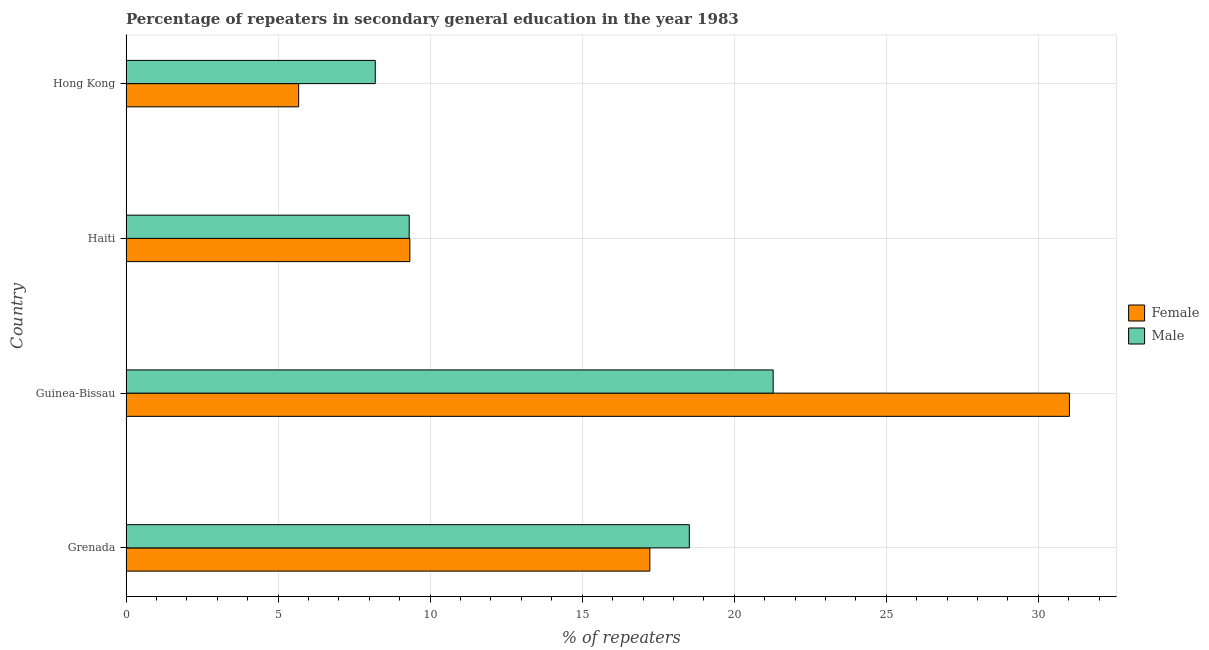How many different coloured bars are there?
Keep it short and to the point. 2. Are the number of bars per tick equal to the number of legend labels?
Give a very brief answer. Yes. What is the label of the 4th group of bars from the top?
Give a very brief answer. Grenada. In how many cases, is the number of bars for a given country not equal to the number of legend labels?
Your answer should be compact. 0. What is the percentage of male repeaters in Guinea-Bissau?
Keep it short and to the point. 21.28. Across all countries, what is the maximum percentage of female repeaters?
Make the answer very short. 31.02. Across all countries, what is the minimum percentage of male repeaters?
Provide a short and direct response. 8.2. In which country was the percentage of male repeaters maximum?
Keep it short and to the point. Guinea-Bissau. In which country was the percentage of female repeaters minimum?
Your answer should be compact. Hong Kong. What is the total percentage of male repeaters in the graph?
Provide a short and direct response. 57.31. What is the difference between the percentage of male repeaters in Grenada and that in Haiti?
Keep it short and to the point. 9.21. What is the difference between the percentage of male repeaters in Haiti and the percentage of female repeaters in Guinea-Bissau?
Provide a succinct answer. -21.71. What is the average percentage of female repeaters per country?
Your answer should be compact. 15.81. What is the difference between the percentage of male repeaters and percentage of female repeaters in Hong Kong?
Offer a very short reply. 2.52. In how many countries, is the percentage of female repeaters greater than 6 %?
Offer a very short reply. 3. What is the ratio of the percentage of female repeaters in Grenada to that in Guinea-Bissau?
Your answer should be compact. 0.56. Is the percentage of male repeaters in Grenada less than that in Guinea-Bissau?
Your answer should be compact. Yes. What is the difference between the highest and the second highest percentage of male repeaters?
Make the answer very short. 2.76. What is the difference between the highest and the lowest percentage of female repeaters?
Offer a very short reply. 25.34. In how many countries, is the percentage of male repeaters greater than the average percentage of male repeaters taken over all countries?
Your answer should be compact. 2. Is the sum of the percentage of male repeaters in Guinea-Bissau and Haiti greater than the maximum percentage of female repeaters across all countries?
Make the answer very short. No. What does the 2nd bar from the top in Haiti represents?
Ensure brevity in your answer.  Female. What does the 1st bar from the bottom in Guinea-Bissau represents?
Offer a very short reply. Female. Are all the bars in the graph horizontal?
Offer a terse response. Yes. What is the difference between two consecutive major ticks on the X-axis?
Ensure brevity in your answer.  5. Does the graph contain grids?
Provide a short and direct response. Yes. How many legend labels are there?
Provide a short and direct response. 2. How are the legend labels stacked?
Ensure brevity in your answer.  Vertical. What is the title of the graph?
Keep it short and to the point. Percentage of repeaters in secondary general education in the year 1983. What is the label or title of the X-axis?
Provide a short and direct response. % of repeaters. What is the % of repeaters in Female in Grenada?
Make the answer very short. 17.22. What is the % of repeaters in Male in Grenada?
Your answer should be compact. 18.52. What is the % of repeaters of Female in Guinea-Bissau?
Provide a succinct answer. 31.02. What is the % of repeaters in Male in Guinea-Bissau?
Provide a succinct answer. 21.28. What is the % of repeaters of Female in Haiti?
Your answer should be compact. 9.33. What is the % of repeaters of Male in Haiti?
Provide a short and direct response. 9.31. What is the % of repeaters in Female in Hong Kong?
Keep it short and to the point. 5.68. What is the % of repeaters of Male in Hong Kong?
Make the answer very short. 8.2. Across all countries, what is the maximum % of repeaters of Female?
Provide a short and direct response. 31.02. Across all countries, what is the maximum % of repeaters of Male?
Your answer should be very brief. 21.28. Across all countries, what is the minimum % of repeaters in Female?
Keep it short and to the point. 5.68. Across all countries, what is the minimum % of repeaters in Male?
Your response must be concise. 8.2. What is the total % of repeaters of Female in the graph?
Make the answer very short. 63.25. What is the total % of repeaters of Male in the graph?
Provide a succinct answer. 57.31. What is the difference between the % of repeaters in Female in Grenada and that in Guinea-Bissau?
Provide a succinct answer. -13.8. What is the difference between the % of repeaters of Male in Grenada and that in Guinea-Bissau?
Keep it short and to the point. -2.76. What is the difference between the % of repeaters in Female in Grenada and that in Haiti?
Your response must be concise. 7.89. What is the difference between the % of repeaters in Male in Grenada and that in Haiti?
Your answer should be very brief. 9.21. What is the difference between the % of repeaters in Female in Grenada and that in Hong Kong?
Your response must be concise. 11.55. What is the difference between the % of repeaters of Male in Grenada and that in Hong Kong?
Provide a succinct answer. 10.33. What is the difference between the % of repeaters of Female in Guinea-Bissau and that in Haiti?
Offer a terse response. 21.69. What is the difference between the % of repeaters of Male in Guinea-Bissau and that in Haiti?
Give a very brief answer. 11.97. What is the difference between the % of repeaters in Female in Guinea-Bissau and that in Hong Kong?
Provide a short and direct response. 25.34. What is the difference between the % of repeaters of Male in Guinea-Bissau and that in Hong Kong?
Keep it short and to the point. 13.08. What is the difference between the % of repeaters in Female in Haiti and that in Hong Kong?
Your answer should be very brief. 3.66. What is the difference between the % of repeaters in Male in Haiti and that in Hong Kong?
Your response must be concise. 1.12. What is the difference between the % of repeaters in Female in Grenada and the % of repeaters in Male in Guinea-Bissau?
Make the answer very short. -4.06. What is the difference between the % of repeaters of Female in Grenada and the % of repeaters of Male in Haiti?
Give a very brief answer. 7.91. What is the difference between the % of repeaters of Female in Grenada and the % of repeaters of Male in Hong Kong?
Offer a terse response. 9.03. What is the difference between the % of repeaters of Female in Guinea-Bissau and the % of repeaters of Male in Haiti?
Ensure brevity in your answer.  21.71. What is the difference between the % of repeaters of Female in Guinea-Bissau and the % of repeaters of Male in Hong Kong?
Give a very brief answer. 22.82. What is the difference between the % of repeaters in Female in Haiti and the % of repeaters in Male in Hong Kong?
Offer a terse response. 1.14. What is the average % of repeaters of Female per country?
Your answer should be very brief. 15.81. What is the average % of repeaters of Male per country?
Provide a short and direct response. 14.33. What is the difference between the % of repeaters in Female and % of repeaters in Male in Grenada?
Give a very brief answer. -1.3. What is the difference between the % of repeaters in Female and % of repeaters in Male in Guinea-Bissau?
Your answer should be compact. 9.74. What is the difference between the % of repeaters in Female and % of repeaters in Male in Haiti?
Your response must be concise. 0.02. What is the difference between the % of repeaters in Female and % of repeaters in Male in Hong Kong?
Your answer should be very brief. -2.52. What is the ratio of the % of repeaters of Female in Grenada to that in Guinea-Bissau?
Ensure brevity in your answer.  0.56. What is the ratio of the % of repeaters of Male in Grenada to that in Guinea-Bissau?
Your answer should be very brief. 0.87. What is the ratio of the % of repeaters in Female in Grenada to that in Haiti?
Offer a terse response. 1.85. What is the ratio of the % of repeaters in Male in Grenada to that in Haiti?
Your answer should be very brief. 1.99. What is the ratio of the % of repeaters in Female in Grenada to that in Hong Kong?
Offer a terse response. 3.03. What is the ratio of the % of repeaters in Male in Grenada to that in Hong Kong?
Your response must be concise. 2.26. What is the ratio of the % of repeaters of Female in Guinea-Bissau to that in Haiti?
Your answer should be very brief. 3.32. What is the ratio of the % of repeaters of Male in Guinea-Bissau to that in Haiti?
Offer a very short reply. 2.29. What is the ratio of the % of repeaters of Female in Guinea-Bissau to that in Hong Kong?
Give a very brief answer. 5.46. What is the ratio of the % of repeaters in Male in Guinea-Bissau to that in Hong Kong?
Provide a succinct answer. 2.6. What is the ratio of the % of repeaters in Female in Haiti to that in Hong Kong?
Offer a very short reply. 1.64. What is the ratio of the % of repeaters of Male in Haiti to that in Hong Kong?
Ensure brevity in your answer.  1.14. What is the difference between the highest and the second highest % of repeaters in Female?
Your answer should be very brief. 13.8. What is the difference between the highest and the second highest % of repeaters in Male?
Ensure brevity in your answer.  2.76. What is the difference between the highest and the lowest % of repeaters of Female?
Your answer should be very brief. 25.34. What is the difference between the highest and the lowest % of repeaters in Male?
Your answer should be very brief. 13.08. 